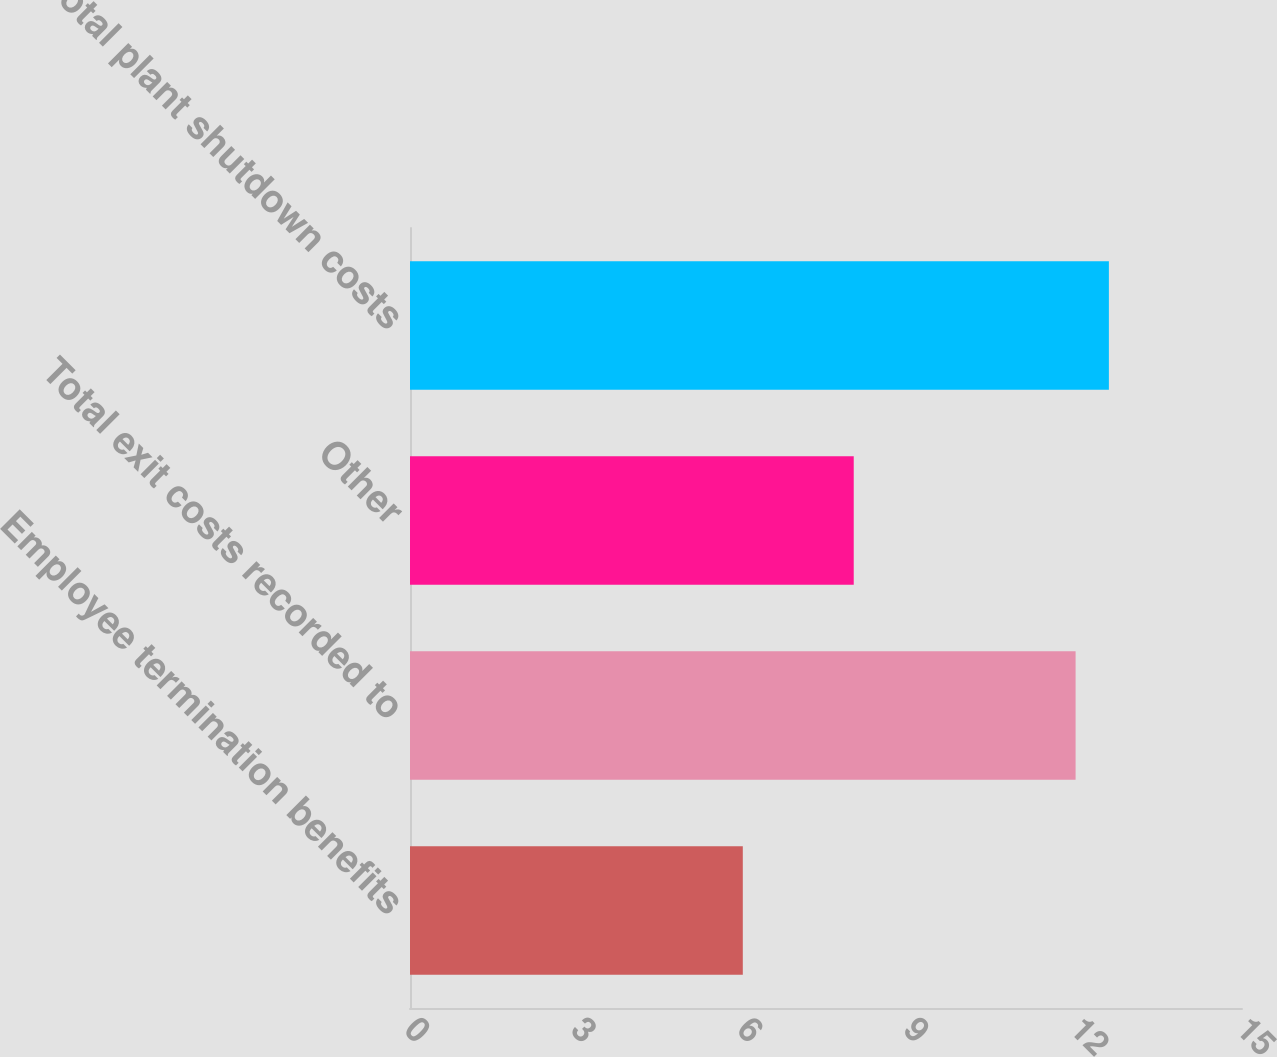Convert chart. <chart><loc_0><loc_0><loc_500><loc_500><bar_chart><fcel>Employee termination benefits<fcel>Total exit costs recorded to<fcel>Other<fcel>Total plant shutdown costs<nl><fcel>6<fcel>12<fcel>8<fcel>12.6<nl></chart> 